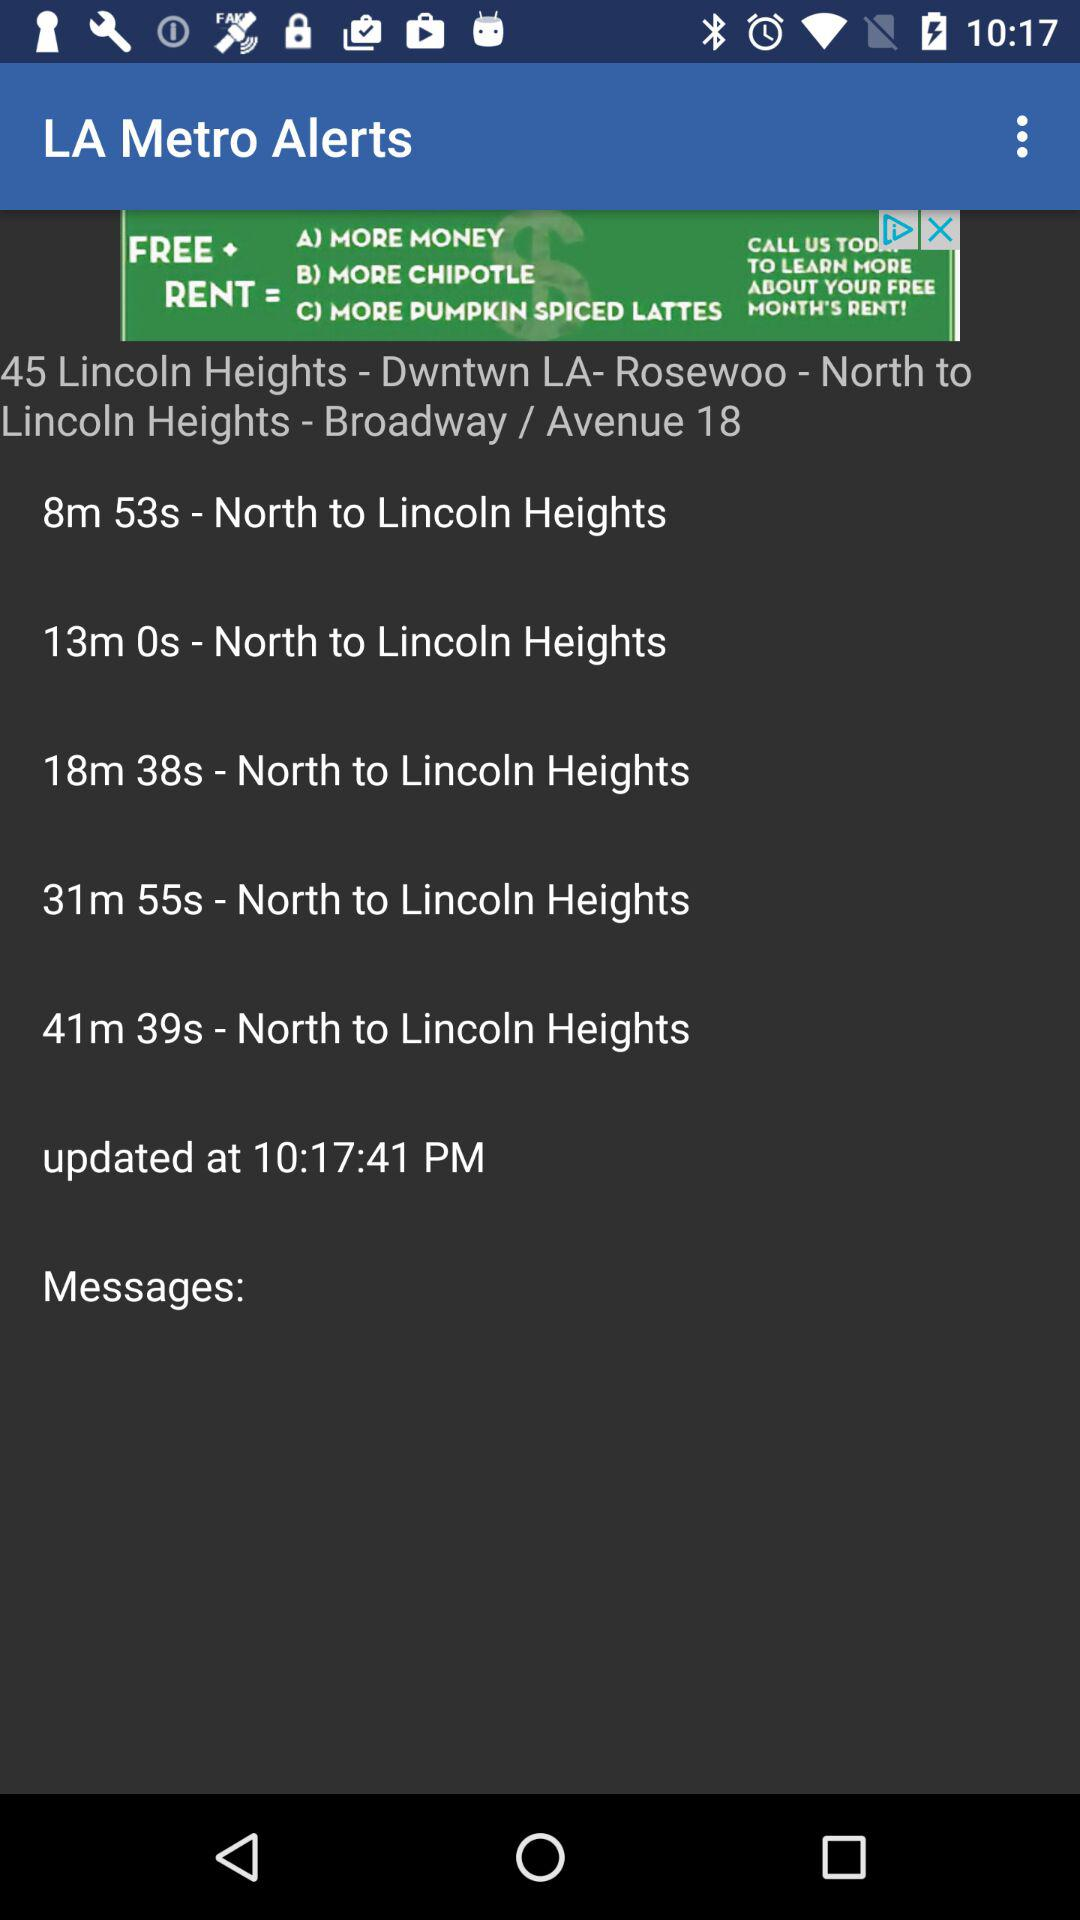What is the given time for North to Lincoln Heights?
When the provided information is insufficient, respond with <no answer>. <no answer> 